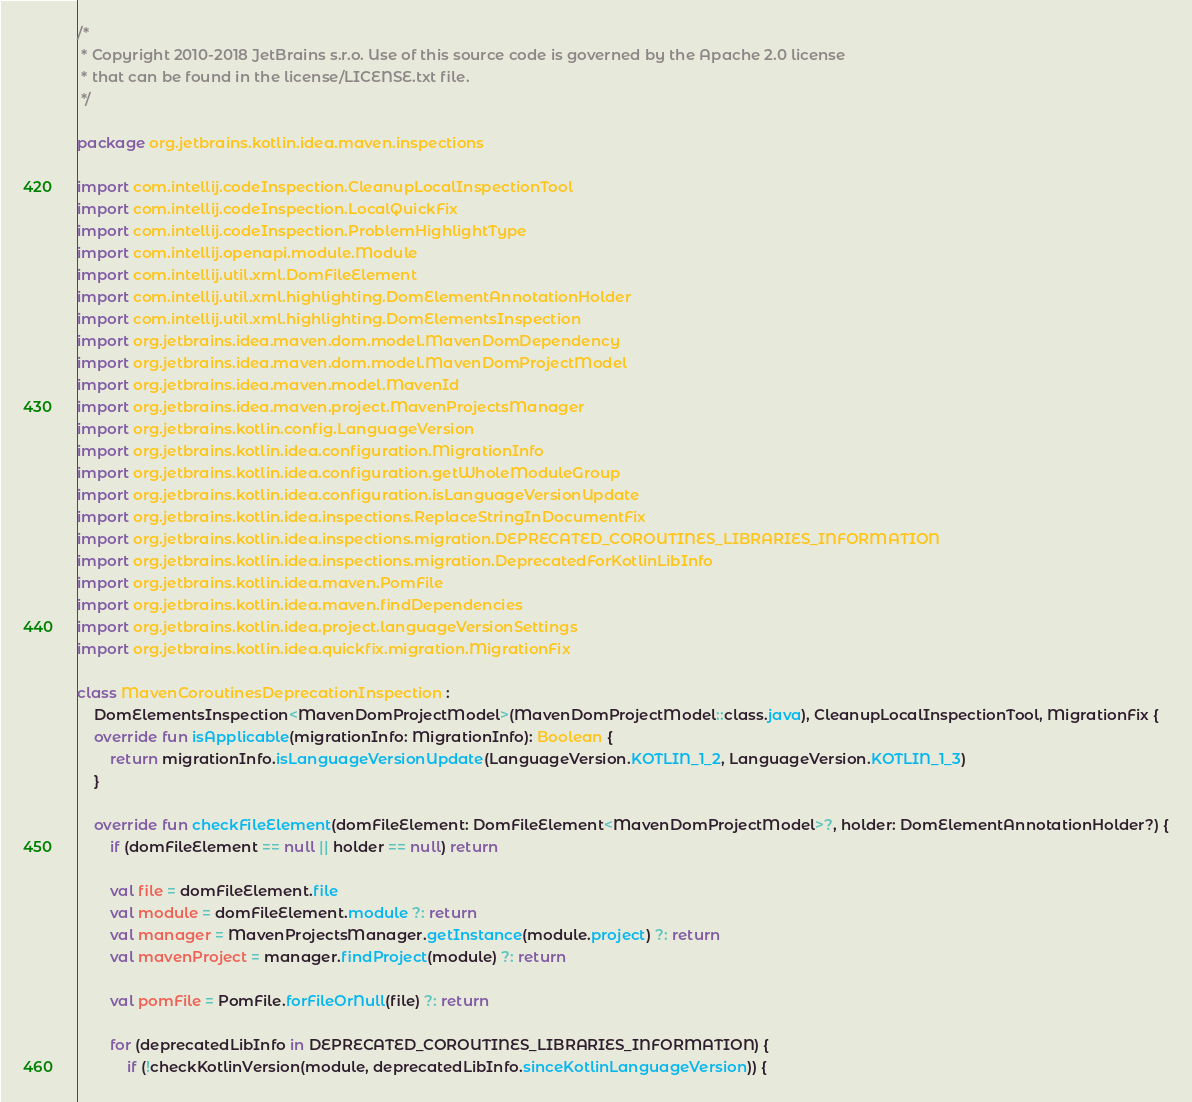Convert code to text. <code><loc_0><loc_0><loc_500><loc_500><_Kotlin_>/*
 * Copyright 2010-2018 JetBrains s.r.o. Use of this source code is governed by the Apache 2.0 license
 * that can be found in the license/LICENSE.txt file.
 */

package org.jetbrains.kotlin.idea.maven.inspections

import com.intellij.codeInspection.CleanupLocalInspectionTool
import com.intellij.codeInspection.LocalQuickFix
import com.intellij.codeInspection.ProblemHighlightType
import com.intellij.openapi.module.Module
import com.intellij.util.xml.DomFileElement
import com.intellij.util.xml.highlighting.DomElementAnnotationHolder
import com.intellij.util.xml.highlighting.DomElementsInspection
import org.jetbrains.idea.maven.dom.model.MavenDomDependency
import org.jetbrains.idea.maven.dom.model.MavenDomProjectModel
import org.jetbrains.idea.maven.model.MavenId
import org.jetbrains.idea.maven.project.MavenProjectsManager
import org.jetbrains.kotlin.config.LanguageVersion
import org.jetbrains.kotlin.idea.configuration.MigrationInfo
import org.jetbrains.kotlin.idea.configuration.getWholeModuleGroup
import org.jetbrains.kotlin.idea.configuration.isLanguageVersionUpdate
import org.jetbrains.kotlin.idea.inspections.ReplaceStringInDocumentFix
import org.jetbrains.kotlin.idea.inspections.migration.DEPRECATED_COROUTINES_LIBRARIES_INFORMATION
import org.jetbrains.kotlin.idea.inspections.migration.DeprecatedForKotlinLibInfo
import org.jetbrains.kotlin.idea.maven.PomFile
import org.jetbrains.kotlin.idea.maven.findDependencies
import org.jetbrains.kotlin.idea.project.languageVersionSettings
import org.jetbrains.kotlin.idea.quickfix.migration.MigrationFix

class MavenCoroutinesDeprecationInspection :
    DomElementsInspection<MavenDomProjectModel>(MavenDomProjectModel::class.java), CleanupLocalInspectionTool, MigrationFix {
    override fun isApplicable(migrationInfo: MigrationInfo): Boolean {
        return migrationInfo.isLanguageVersionUpdate(LanguageVersion.KOTLIN_1_2, LanguageVersion.KOTLIN_1_3)
    }

    override fun checkFileElement(domFileElement: DomFileElement<MavenDomProjectModel>?, holder: DomElementAnnotationHolder?) {
        if (domFileElement == null || holder == null) return

        val file = domFileElement.file
        val module = domFileElement.module ?: return
        val manager = MavenProjectsManager.getInstance(module.project) ?: return
        val mavenProject = manager.findProject(module) ?: return

        val pomFile = PomFile.forFileOrNull(file) ?: return

        for (deprecatedLibInfo in DEPRECATED_COROUTINES_LIBRARIES_INFORMATION) {
            if (!checkKotlinVersion(module, deprecatedLibInfo.sinceKotlinLanguageVersion)) {</code> 